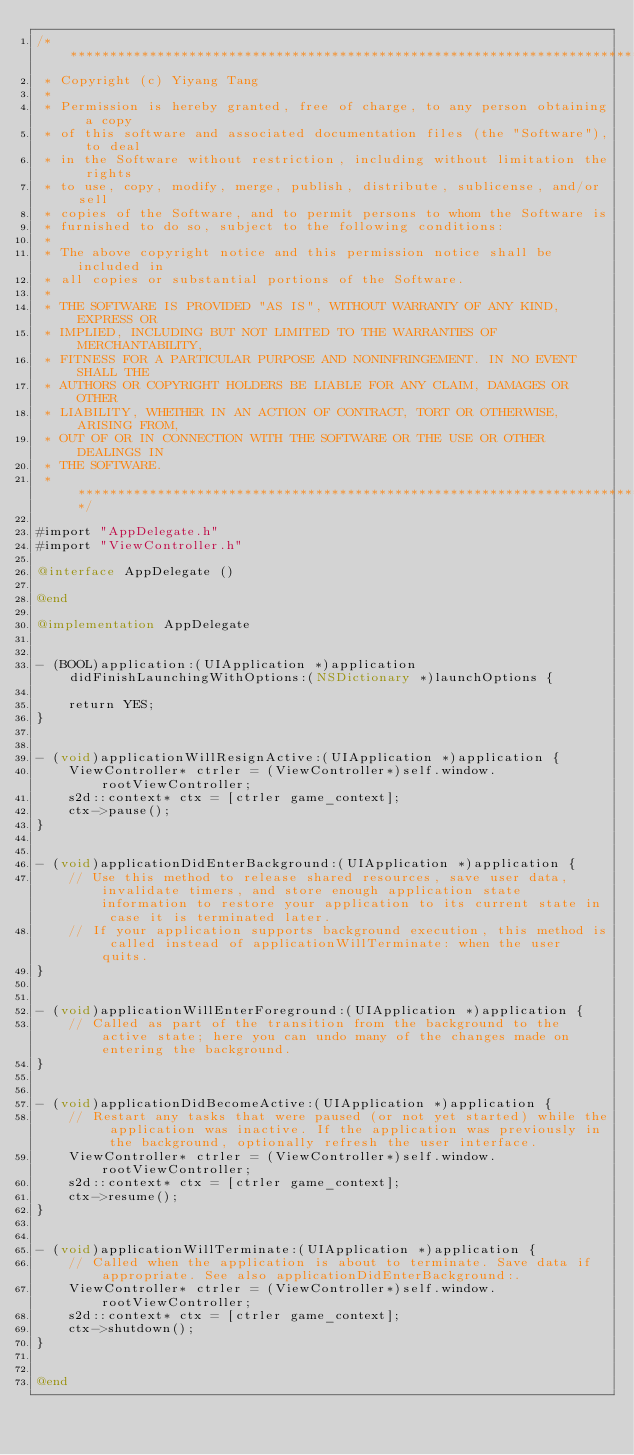<code> <loc_0><loc_0><loc_500><loc_500><_ObjectiveC_>/****************************************************************************
 * Copyright (c) Yiyang Tang
 *
 * Permission is hereby granted, free of charge, to any person obtaining a copy
 * of this software and associated documentation files (the "Software"), to deal
 * in the Software without restriction, including without limitation the rights
 * to use, copy, modify, merge, publish, distribute, sublicense, and/or sell
 * copies of the Software, and to permit persons to whom the Software is
 * furnished to do so, subject to the following conditions:
 *
 * The above copyright notice and this permission notice shall be included in
 * all copies or substantial portions of the Software.
 *
 * THE SOFTWARE IS PROVIDED "AS IS", WITHOUT WARRANTY OF ANY KIND, EXPRESS OR
 * IMPLIED, INCLUDING BUT NOT LIMITED TO THE WARRANTIES OF MERCHANTABILITY,
 * FITNESS FOR A PARTICULAR PURPOSE AND NONINFRINGEMENT. IN NO EVENT SHALL THE
 * AUTHORS OR COPYRIGHT HOLDERS BE LIABLE FOR ANY CLAIM, DAMAGES OR OTHER
 * LIABILITY, WHETHER IN AN ACTION OF CONTRACT, TORT OR OTHERWISE, ARISING FROM,
 * OUT OF OR IN CONNECTION WITH THE SOFTWARE OR THE USE OR OTHER DEALINGS IN
 * THE SOFTWARE.
 * ****************************************************************************/

#import "AppDelegate.h"
#import "ViewController.h"

@interface AppDelegate ()

@end

@implementation AppDelegate


- (BOOL)application:(UIApplication *)application didFinishLaunchingWithOptions:(NSDictionary *)launchOptions {

    return YES;
}


- (void)applicationWillResignActive:(UIApplication *)application {
    ViewController* ctrler = (ViewController*)self.window.rootViewController;
    s2d::context* ctx = [ctrler game_context];
    ctx->pause();
}


- (void)applicationDidEnterBackground:(UIApplication *)application {
    // Use this method to release shared resources, save user data, invalidate timers, and store enough application state information to restore your application to its current state in case it is terminated later.
    // If your application supports background execution, this method is called instead of applicationWillTerminate: when the user quits.
}


- (void)applicationWillEnterForeground:(UIApplication *)application {
    // Called as part of the transition from the background to the active state; here you can undo many of the changes made on entering the background.
}


- (void)applicationDidBecomeActive:(UIApplication *)application {
    // Restart any tasks that were paused (or not yet started) while the application was inactive. If the application was previously in the background, optionally refresh the user interface.
    ViewController* ctrler = (ViewController*)self.window.rootViewController;
    s2d::context* ctx = [ctrler game_context];
    ctx->resume();
}


- (void)applicationWillTerminate:(UIApplication *)application {
    // Called when the application is about to terminate. Save data if appropriate. See also applicationDidEnterBackground:.
    ViewController* ctrler = (ViewController*)self.window.rootViewController;
    s2d::context* ctx = [ctrler game_context];
    ctx->shutdown();
}


@end
</code> 